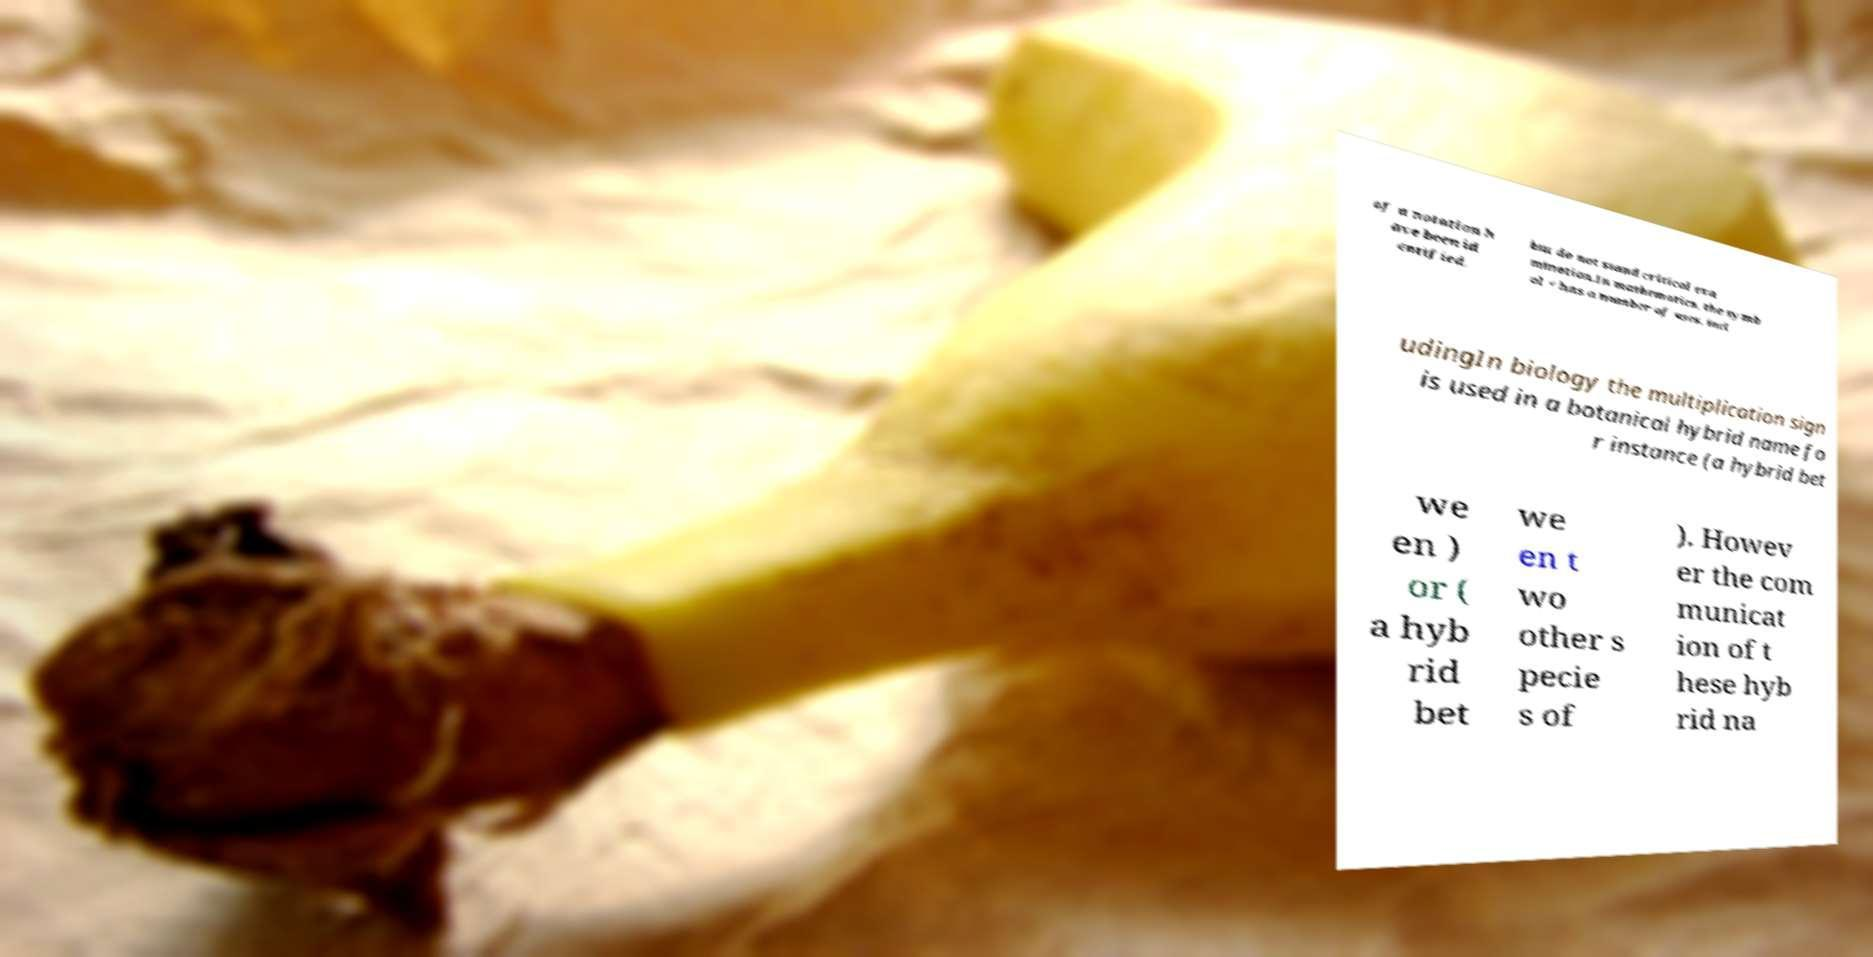There's text embedded in this image that I need extracted. Can you transcribe it verbatim? of a notation h ave been id entified, but do not stand critical exa mination.In mathematics, the symb ol × has a number of uses, incl udingIn biology the multiplication sign is used in a botanical hybrid name fo r instance (a hybrid bet we en ) or ( a hyb rid bet we en t wo other s pecie s of ). Howev er the com municat ion of t hese hyb rid na 